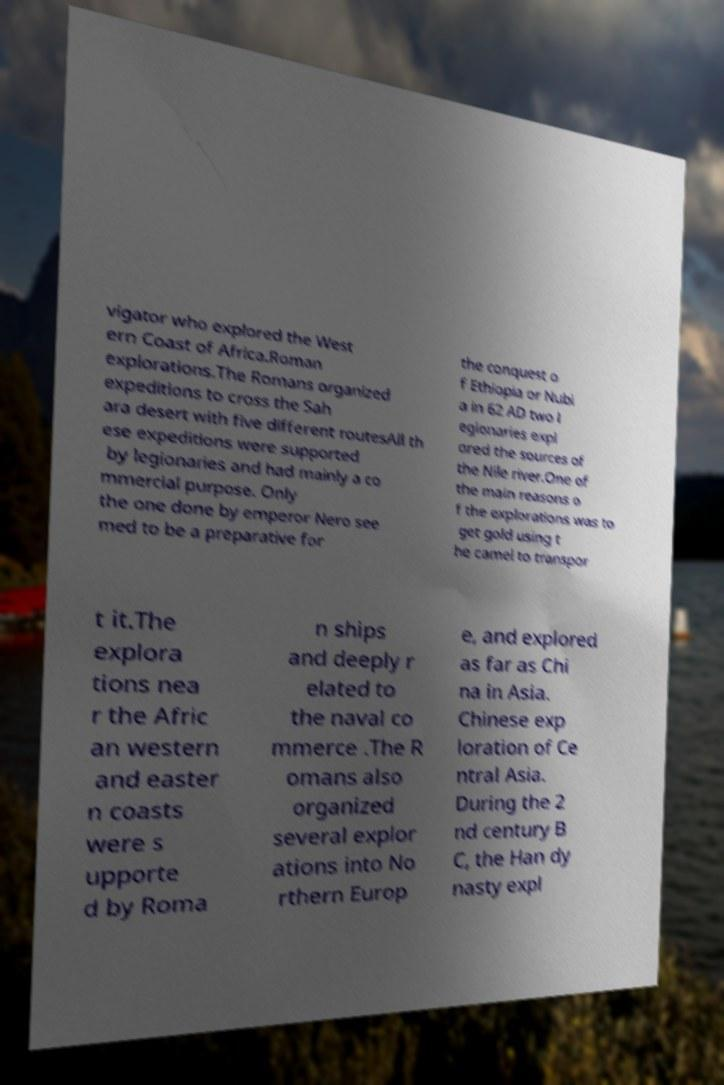What messages or text are displayed in this image? I need them in a readable, typed format. vigator who explored the West ern Coast of Africa.Roman explorations.The Romans organized expeditions to cross the Sah ara desert with five different routesAll th ese expeditions were supported by legionaries and had mainly a co mmercial purpose. Only the one done by emperor Nero see med to be a preparative for the conquest o f Ethiopia or Nubi a in 62 AD two l egionaries expl ored the sources of the Nile river.One of the main reasons o f the explorations was to get gold using t he camel to transpor t it.The explora tions nea r the Afric an western and easter n coasts were s upporte d by Roma n ships and deeply r elated to the naval co mmerce .The R omans also organized several explor ations into No rthern Europ e, and explored as far as Chi na in Asia. Chinese exp loration of Ce ntral Asia. During the 2 nd century B C, the Han dy nasty expl 